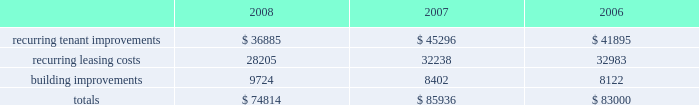Customary conditions .
We will retain a 20% ( 20 % ) equity interest in the joint venture .
As of december 31 , 2008 , the joint venture has acquired seven properties from us and we received year-to-date net sale proceeds and financing distributions of approximately $ 251.6 million .
In january 2008 , we sold a tract of land to an unconsolidated joint venture in which we hold a 50% ( 50 % ) equity interest and received a distribution , commensurate to our partner 2019s 50% ( 50 % ) ownership interest , of approximately $ 38.3 million .
In november 2008 , that unconsolidated joint venture entered a loan agreement with a consortium of banks and distributed a portion of the loan proceeds to us and our partner , with our share of the distribution totaling $ 20.4 million .
Uses of liquidity our principal uses of liquidity include the following : 2022 property investment ; 2022 recurring leasing/capital costs ; 2022 dividends and distributions to shareholders and unitholders ; 2022 long-term debt maturities ; 2022 opportunistic repurchases of outstanding debt ; and 2022 other contractual obligations .
Property investment we evaluate development and acquisition opportunities based upon market outlook , supply and long-term growth potential .
Our ability to make future property investments is dependent upon our continued access to our longer-term sources of liquidity including the issuances of debt or equity securities as well as disposing of selected properties .
In light of current economic conditions , management continues to evaluate our investment priorities and we are limiting new development expenditures .
Recurring expenditures one of our principal uses of our liquidity is to fund the recurring leasing/capital expenditures of our real estate investments .
The following is a summary of our recurring capital expenditures for the years ended december 31 , 2008 , 2007 and 2006 , respectively ( in thousands ) : .
Dividends and distributions in order to qualify as a reit for federal income tax purposes , we must currently distribute at least 90% ( 90 % ) of our taxable income to shareholders .
Because depreciation is a non-cash expense , cash flow will typically be greater than operating income .
We paid dividends per share of $ 1.93 , $ 1.91 and $ 1.89 for the years ended december 31 , 2008 , 2007 and 2006 , respectively .
We expect to continue to distribute taxable earnings to meet the requirements to maintain our reit status .
However , distributions are declared at the discretion of our board of directors and are subject to actual cash available for distribution , our financial condition , capital requirements and such other factors as our board of directors deems relevant . in january 2009 , our board of directors resolved to decrease our annual dividend from $ 1.94 per share to $ 1.00 per share in order to retain additional cash to help meet our capital needs .
We anticipate retaining additional cash of approximately $ 145.2 million per year , when compared to an annual dividend of $ 1.94 per share , as the result of this action .
At december 31 , 2008 we had six series of preferred shares outstanding .
The annual dividend rates on our preferred shares range between 6.5% ( 6.5 % ) and 8.375% ( 8.375 % ) and are paid in arrears quarterly. .
In 2008 what was the percent of the recurring capital expenditures associated with leasing costs? 
Computations: (28205 / 74814)
Answer: 0.377. 